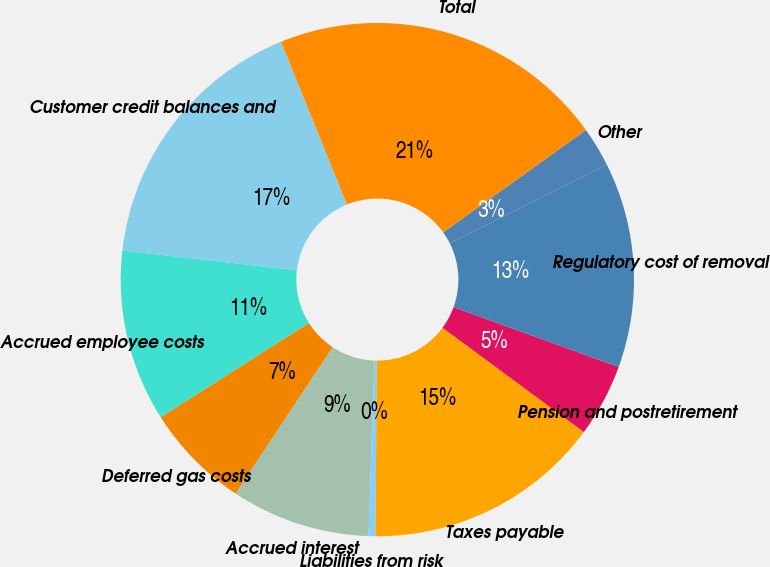Convert chart to OTSL. <chart><loc_0><loc_0><loc_500><loc_500><pie_chart><fcel>Customer credit balances and<fcel>Accrued employee costs<fcel>Deferred gas costs<fcel>Accrued interest<fcel>Liabilities from risk<fcel>Taxes payable<fcel>Pension and postretirement<fcel>Regulatory cost of removal<fcel>Other<fcel>Total<nl><fcel>17.06%<fcel>10.83%<fcel>6.68%<fcel>8.75%<fcel>0.44%<fcel>14.99%<fcel>4.6%<fcel>12.91%<fcel>2.52%<fcel>21.22%<nl></chart> 